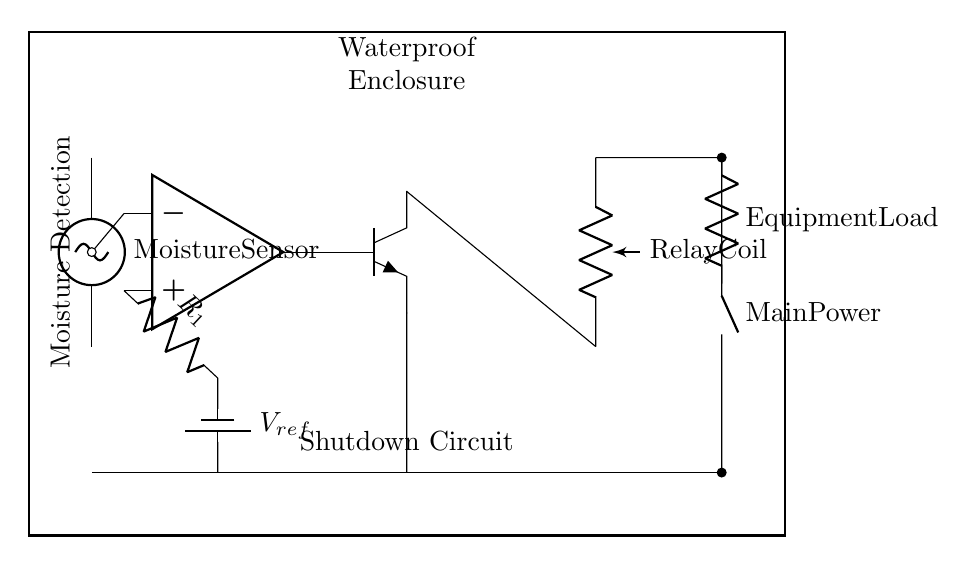What component is used for moisture detection? The circuit diagram shows a moisture sensor, which is specifically labeled in the diagram as the component at the top-left connecting to the circuit.
Answer: Moisture Sensor What type of transistor is used in this circuit? The circuit diagram indicates an NPN transistor. The symbol for the transistor clearly shows the orientation and type, identifying it as NPN.
Answer: NPN What is the role of the relay in this circuit? In this circuit, the relay functions to switch the load equipment on or off based on the moisture detection signal. It is identified as a relay coil in the diagram, directly connected to the transistor.
Answer: Switch load What voltage is used as reference in the comparator? The circuit highlights that the reference voltage is denoted as V subscript ref, which is linked to a resistor connected to the inverting input of the comparator.
Answer: V ref How does the circuit respond to moisture detected by the sensor? The circuit engages the comparator, which, upon detecting moisture due to the sensor, activates the NPN transistor to energize the relay, thereby shutting down the equipment load to prevent damage. It involves multiple components working together in response to the moisture detection.
Answer: Activates shutdown What component provides the main power to the circuit? The main power source is labeled in the circuit diagram as 'Main Power,' clearly indicating its function as the supply for the entire circuit.
Answer: Main Power What is the purpose of resistor R1 in this circuit? The resistor R1 serves as a part of the voltage divider that helps set the reference voltage for comparison in the comparator. Its role is to influence the voltage levels at the inputs.
Answer: Set reference voltage 